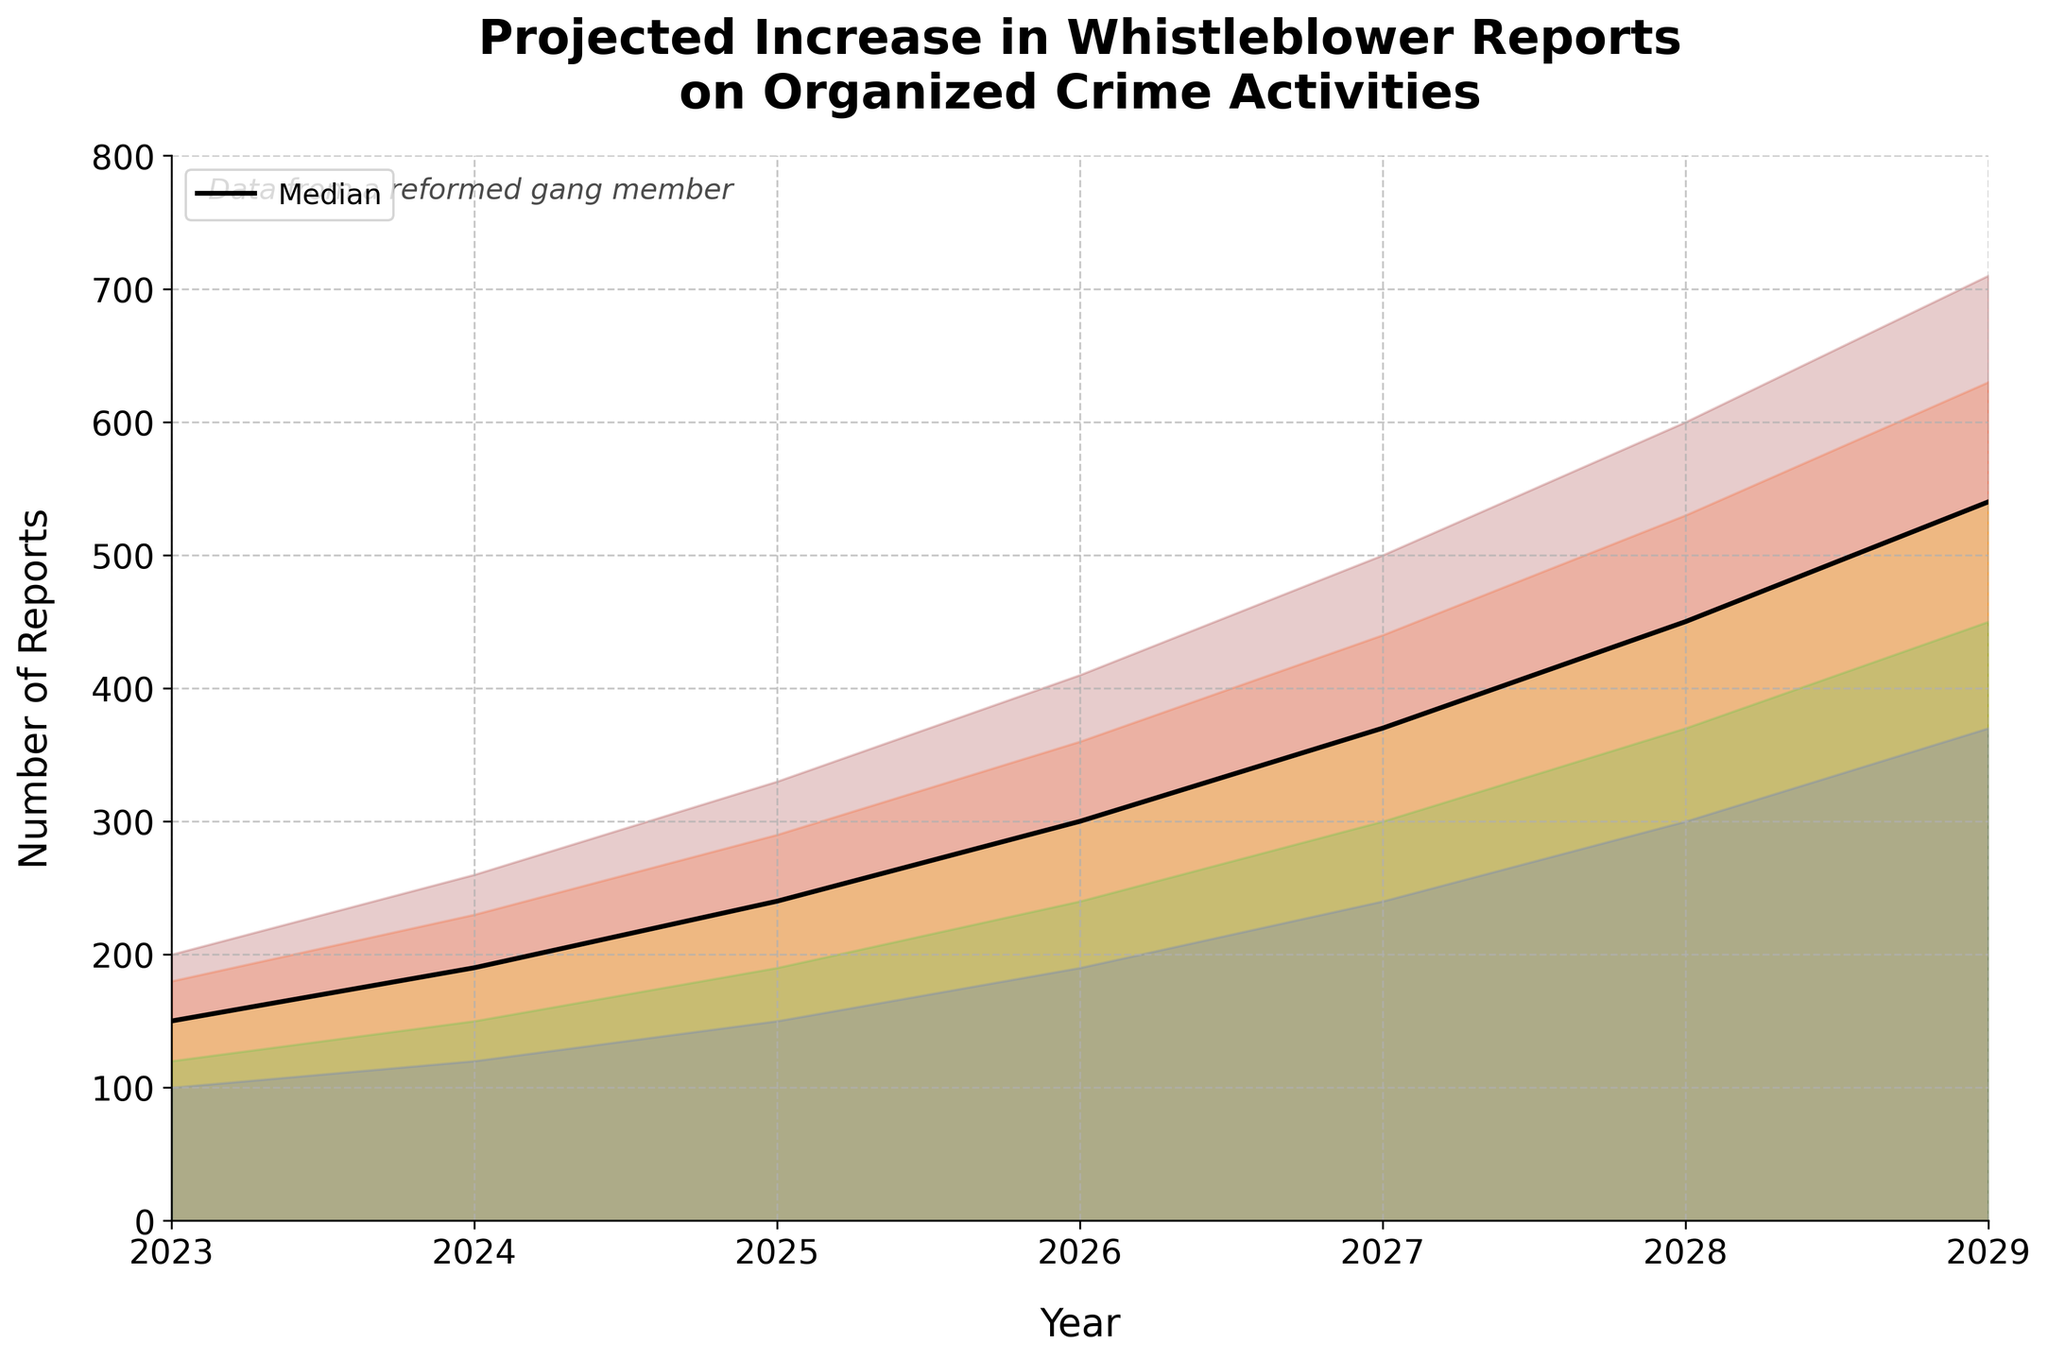What is the title of the chart? The title of the chart is located at the top and is generally the largest text in the figure.
Answer: Projected Increase in Whistleblower Reports on Organized Crime Activities How many years' worth of data are depicted in the chart? The x-axis typically represents the timeline. By counting the number of distinct points or labels, we can determine the number of years covered.
Answer: 7 years Which year has the highest median value projected for whistleblower reports? By examining the black line that represents the median (Mid) values, and finding the highest point along this line, we can determine the year with the highest median projection.
Answer: 2029 What is the range of the projected number of reports in 2026? The range can be found by looking at the lowest (Low) and highest (High) projections for the specified year. Check the corresponding values on the y-axis.
Answer: 190 to 410 How much is the median value expected to increase from 2023 to 2029? The increase can be calculated by finding the difference between the median (Mid) value in 2023 and the median value in 2029.
Answer: 390 - 150 = 240 What are the colors used to represent the different scenarios in the chart? The color scheme of the chart can be identified by observing the shaded areas and their respective labels, if available.
Answer: Dark red, orange, yellow, green, blue In which year is the difference between the Low and High projections the largest? For each year, calculate the difference between the Low and High projections. Identify the year with the largest difference.
Answer: 2029 (710 - 370 = 340) How does the number of whistleblower reports projected in 2028 under the Low-Mid scenario compare to the number projected in 2024 under the Mid-High scenario? By comparing the specific values for Low-Mid in 2028 and Mid-High in 2024, we determine which is higher or lower.
Answer: 370 (Low-Mid 2028) compared to 230 (Mid-High 2024), so 370 > 230 What is the approximate average increase in the Low projection for whistleblower reports per year? Calculate the annual increases in the Low projection values, sum them, and then divide by the number of years.
Answer: (120-100 + 150-120 + 190-150 + 240-190 + 300-240 + 370-300) / 6 = 45 What does the text at the top left corner of the chart indicate? This text typically serves as a caption or footnote and is meant to provide more context about the data source or chart's origin.
Answer: Data from a reformed gang member 